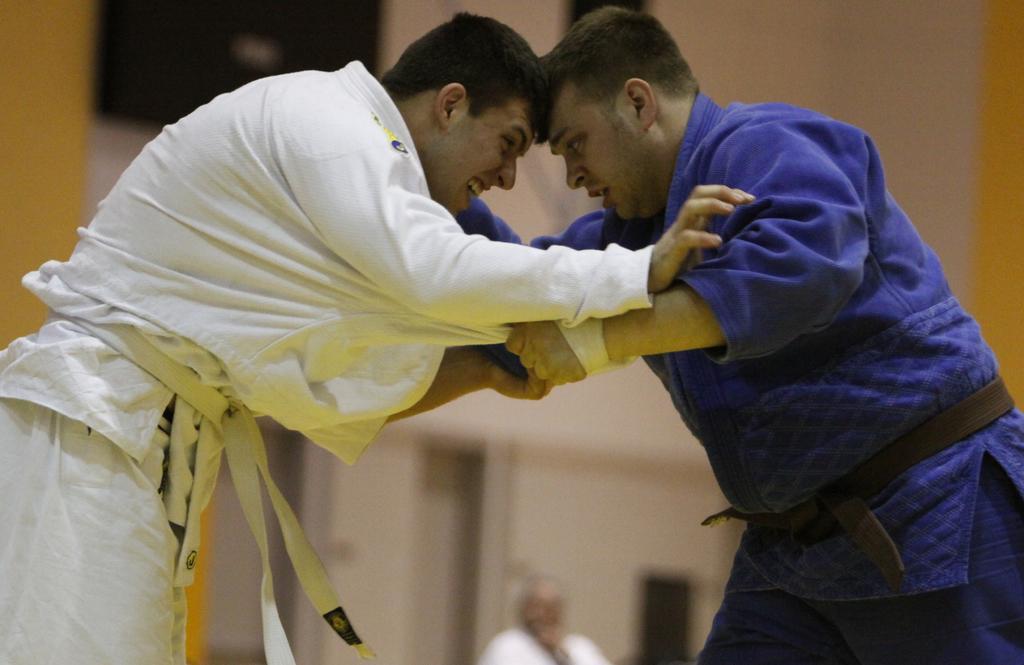In one or two sentences, can you explain what this image depicts? In this image we can see two persons fighting with each other. In the background of the image there is a wall, person and other objects. 